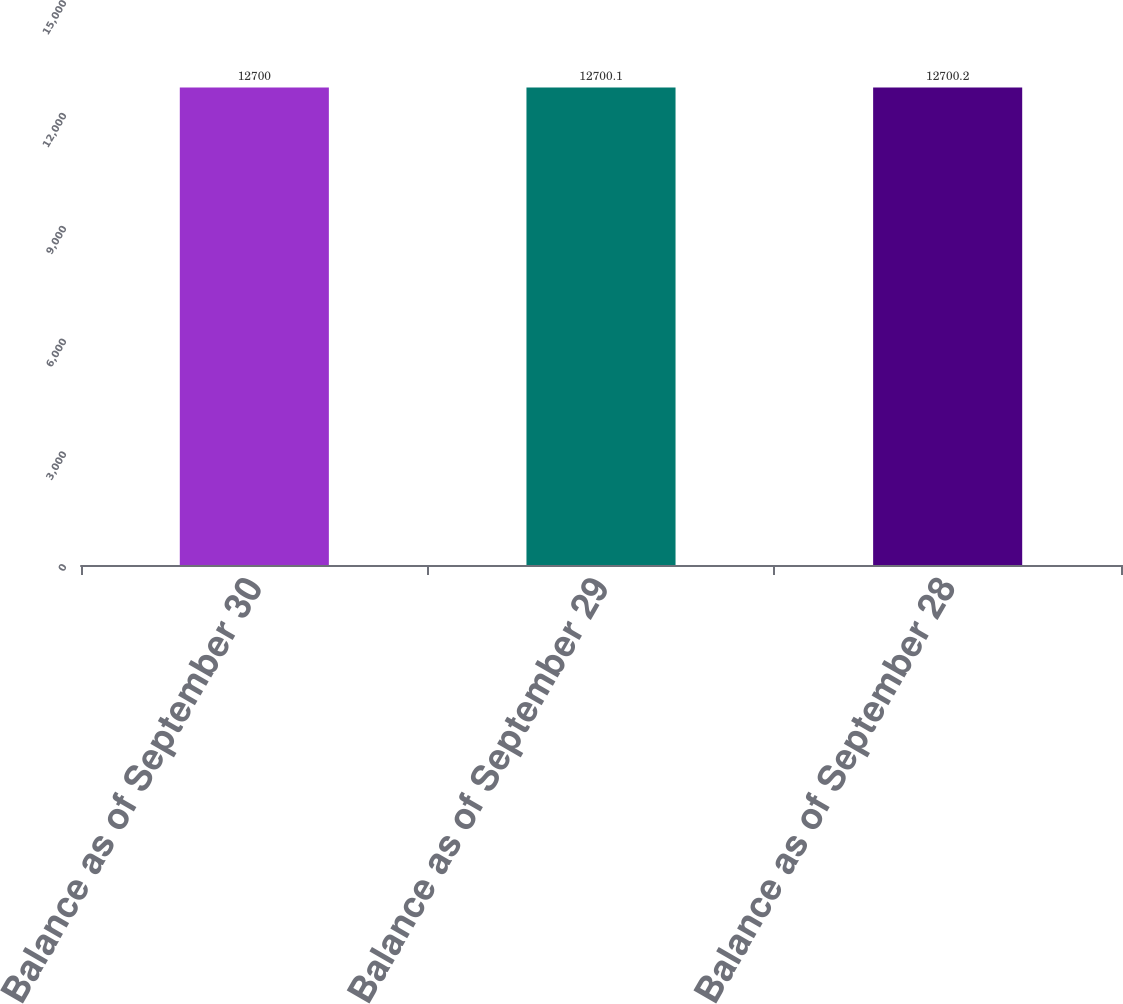<chart> <loc_0><loc_0><loc_500><loc_500><bar_chart><fcel>Balance as of September 30<fcel>Balance as of September 29<fcel>Balance as of September 28<nl><fcel>12700<fcel>12700.1<fcel>12700.2<nl></chart> 